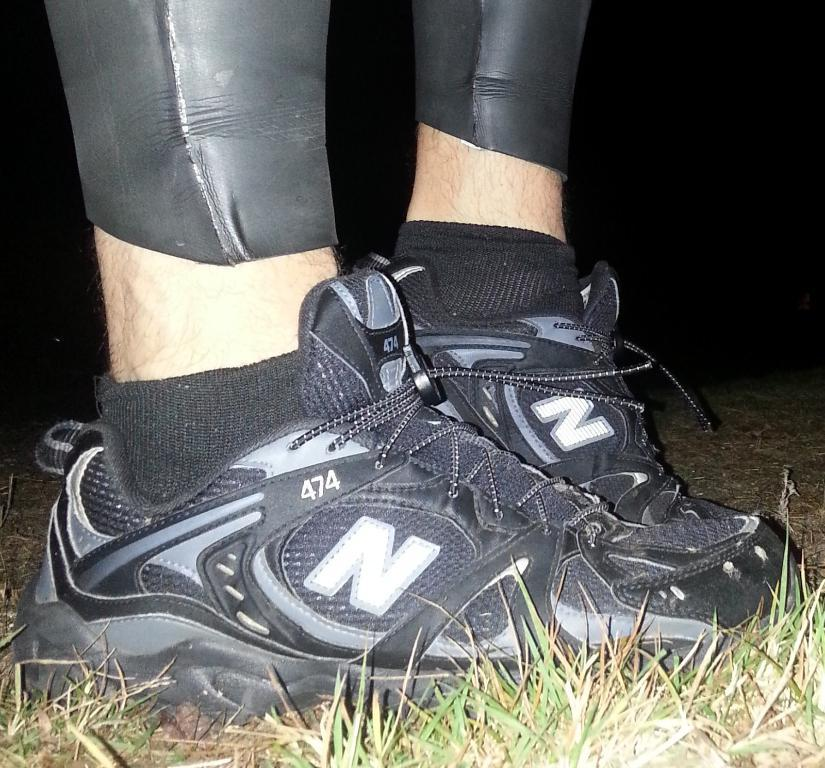What part of a person can be seen in the image? There are legs of a person visible in the image. What type of footwear is the person wearing? The person is wearing black shoes. What type of terrain is at the bottom of the image? There is grass at the bottom of the image. How would you describe the lighting or color of the background in the image? The background of the image is dark. What type of yoke is being used in the image? There is no yoke present in the image. Is the person playing volleyball in the image? There is no indication of volleyball or any sports activity in the image. 